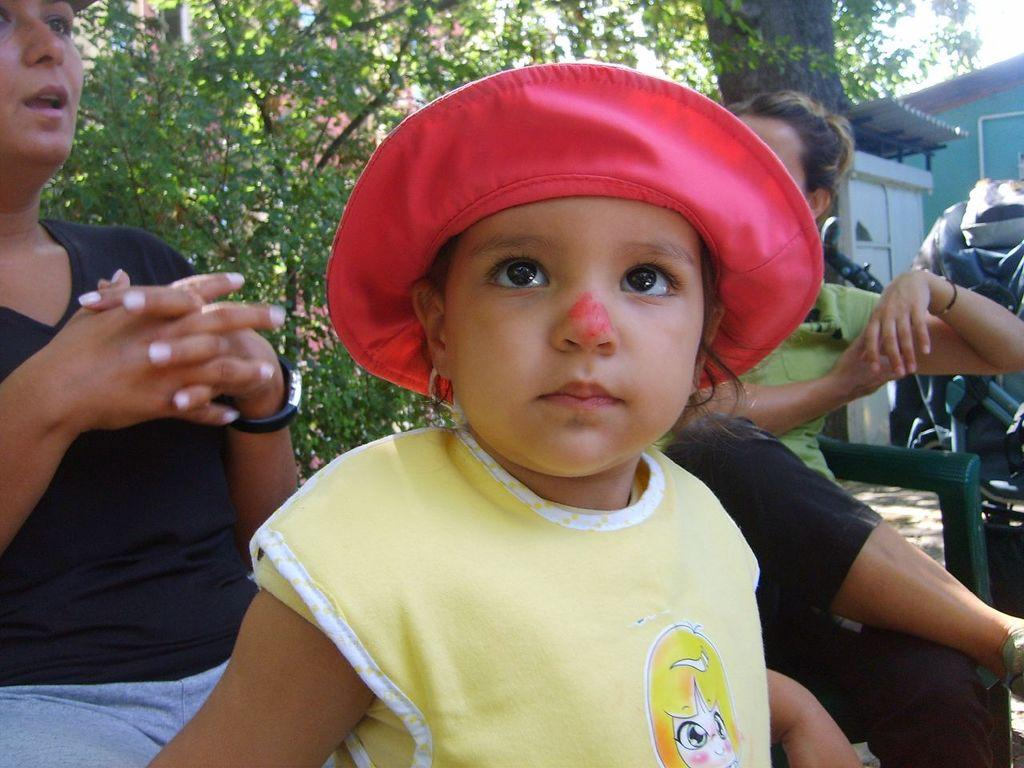What is the kid wearing in the image? The kid is wearing a cap in the image. Where is the kid positioned in the image? The kid is in the center of the image. What are the women doing in the image? The women are sitting on chairs in the image. What type of vegetation can be seen in the image? There are trees visible in the image. What structures can be seen in the image? There is a house and a shed in the image in the image. What type of range can be seen in the image? There is no range present in the image. What type of school can be seen in the image? There is no school present in the image. 